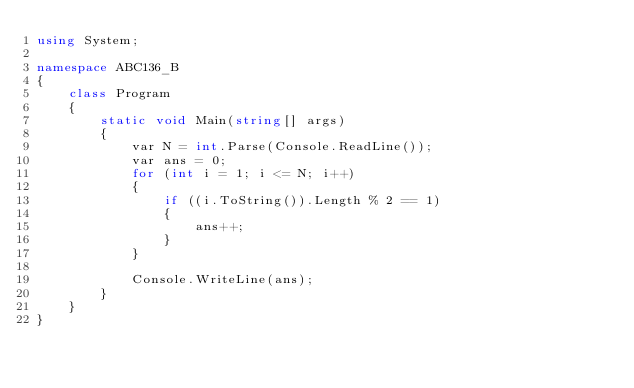<code> <loc_0><loc_0><loc_500><loc_500><_C#_>using System;

namespace ABC136_B
{
    class Program
    {
        static void Main(string[] args)
        {
            var N = int.Parse(Console.ReadLine());
            var ans = 0;
            for (int i = 1; i <= N; i++)
            {
                if ((i.ToString()).Length % 2 == 1)
                {
                    ans++;
                }
            }

            Console.WriteLine(ans);
        }
    }
}
</code> 